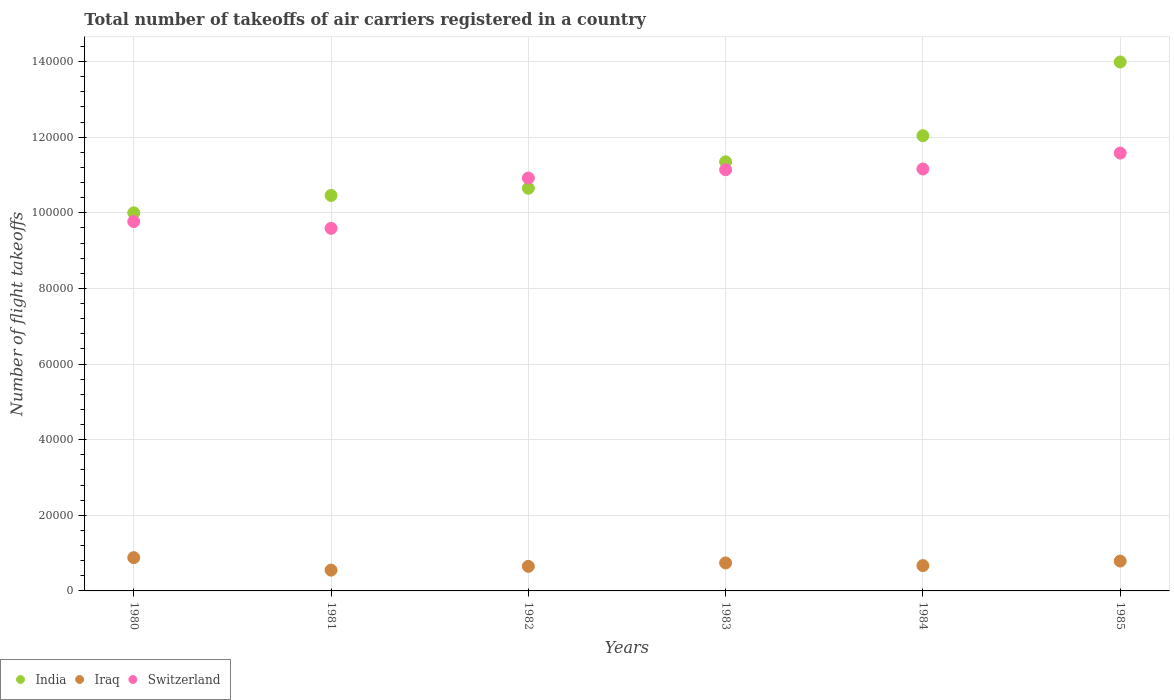How many different coloured dotlines are there?
Make the answer very short. 3. Is the number of dotlines equal to the number of legend labels?
Provide a short and direct response. Yes. What is the total number of flight takeoffs in India in 1981?
Ensure brevity in your answer.  1.05e+05. Across all years, what is the maximum total number of flight takeoffs in Iraq?
Offer a very short reply. 8800. Across all years, what is the minimum total number of flight takeoffs in Switzerland?
Keep it short and to the point. 9.59e+04. What is the total total number of flight takeoffs in India in the graph?
Your answer should be compact. 6.85e+05. What is the difference between the total number of flight takeoffs in India in 1980 and that in 1981?
Your answer should be compact. -4600. What is the difference between the total number of flight takeoffs in Iraq in 1984 and the total number of flight takeoffs in India in 1983?
Offer a very short reply. -1.07e+05. What is the average total number of flight takeoffs in Iraq per year?
Give a very brief answer. 7133.33. In the year 1984, what is the difference between the total number of flight takeoffs in Iraq and total number of flight takeoffs in Switzerland?
Make the answer very short. -1.05e+05. What is the ratio of the total number of flight takeoffs in Switzerland in 1981 to that in 1982?
Make the answer very short. 0.88. What is the difference between the highest and the second highest total number of flight takeoffs in India?
Offer a terse response. 1.95e+04. What is the difference between the highest and the lowest total number of flight takeoffs in Iraq?
Keep it short and to the point. 3300. Is the sum of the total number of flight takeoffs in Iraq in 1980 and 1985 greater than the maximum total number of flight takeoffs in Switzerland across all years?
Keep it short and to the point. No. Is the total number of flight takeoffs in India strictly greater than the total number of flight takeoffs in Switzerland over the years?
Provide a short and direct response. No. How many years are there in the graph?
Ensure brevity in your answer.  6. Are the values on the major ticks of Y-axis written in scientific E-notation?
Provide a succinct answer. No. How are the legend labels stacked?
Your answer should be very brief. Horizontal. What is the title of the graph?
Give a very brief answer. Total number of takeoffs of air carriers registered in a country. Does "Iraq" appear as one of the legend labels in the graph?
Make the answer very short. Yes. What is the label or title of the Y-axis?
Your answer should be compact. Number of flight takeoffs. What is the Number of flight takeoffs in Iraq in 1980?
Ensure brevity in your answer.  8800. What is the Number of flight takeoffs in Switzerland in 1980?
Offer a terse response. 9.77e+04. What is the Number of flight takeoffs of India in 1981?
Ensure brevity in your answer.  1.05e+05. What is the Number of flight takeoffs of Iraq in 1981?
Offer a terse response. 5500. What is the Number of flight takeoffs of Switzerland in 1981?
Make the answer very short. 9.59e+04. What is the Number of flight takeoffs of India in 1982?
Ensure brevity in your answer.  1.06e+05. What is the Number of flight takeoffs in Iraq in 1982?
Offer a terse response. 6500. What is the Number of flight takeoffs in Switzerland in 1982?
Give a very brief answer. 1.09e+05. What is the Number of flight takeoffs in India in 1983?
Provide a short and direct response. 1.14e+05. What is the Number of flight takeoffs in Iraq in 1983?
Ensure brevity in your answer.  7400. What is the Number of flight takeoffs in Switzerland in 1983?
Provide a short and direct response. 1.11e+05. What is the Number of flight takeoffs of India in 1984?
Give a very brief answer. 1.20e+05. What is the Number of flight takeoffs in Iraq in 1984?
Make the answer very short. 6700. What is the Number of flight takeoffs of Switzerland in 1984?
Make the answer very short. 1.12e+05. What is the Number of flight takeoffs in India in 1985?
Your answer should be compact. 1.40e+05. What is the Number of flight takeoffs of Iraq in 1985?
Offer a very short reply. 7900. What is the Number of flight takeoffs in Switzerland in 1985?
Your answer should be compact. 1.16e+05. Across all years, what is the maximum Number of flight takeoffs in India?
Offer a very short reply. 1.40e+05. Across all years, what is the maximum Number of flight takeoffs in Iraq?
Offer a very short reply. 8800. Across all years, what is the maximum Number of flight takeoffs of Switzerland?
Provide a succinct answer. 1.16e+05. Across all years, what is the minimum Number of flight takeoffs of Iraq?
Offer a terse response. 5500. Across all years, what is the minimum Number of flight takeoffs of Switzerland?
Your answer should be very brief. 9.59e+04. What is the total Number of flight takeoffs in India in the graph?
Offer a very short reply. 6.85e+05. What is the total Number of flight takeoffs of Iraq in the graph?
Your answer should be compact. 4.28e+04. What is the total Number of flight takeoffs in Switzerland in the graph?
Offer a very short reply. 6.42e+05. What is the difference between the Number of flight takeoffs of India in 1980 and that in 1981?
Your response must be concise. -4600. What is the difference between the Number of flight takeoffs in Iraq in 1980 and that in 1981?
Provide a short and direct response. 3300. What is the difference between the Number of flight takeoffs in Switzerland in 1980 and that in 1981?
Provide a succinct answer. 1800. What is the difference between the Number of flight takeoffs in India in 1980 and that in 1982?
Keep it short and to the point. -6500. What is the difference between the Number of flight takeoffs in Iraq in 1980 and that in 1982?
Provide a succinct answer. 2300. What is the difference between the Number of flight takeoffs in Switzerland in 1980 and that in 1982?
Offer a very short reply. -1.15e+04. What is the difference between the Number of flight takeoffs in India in 1980 and that in 1983?
Provide a short and direct response. -1.35e+04. What is the difference between the Number of flight takeoffs of Iraq in 1980 and that in 1983?
Provide a succinct answer. 1400. What is the difference between the Number of flight takeoffs in Switzerland in 1980 and that in 1983?
Provide a succinct answer. -1.37e+04. What is the difference between the Number of flight takeoffs in India in 1980 and that in 1984?
Your response must be concise. -2.04e+04. What is the difference between the Number of flight takeoffs in Iraq in 1980 and that in 1984?
Your response must be concise. 2100. What is the difference between the Number of flight takeoffs in Switzerland in 1980 and that in 1984?
Your response must be concise. -1.39e+04. What is the difference between the Number of flight takeoffs in India in 1980 and that in 1985?
Provide a succinct answer. -3.99e+04. What is the difference between the Number of flight takeoffs of Iraq in 1980 and that in 1985?
Provide a succinct answer. 900. What is the difference between the Number of flight takeoffs of Switzerland in 1980 and that in 1985?
Ensure brevity in your answer.  -1.81e+04. What is the difference between the Number of flight takeoffs in India in 1981 and that in 1982?
Keep it short and to the point. -1900. What is the difference between the Number of flight takeoffs of Iraq in 1981 and that in 1982?
Give a very brief answer. -1000. What is the difference between the Number of flight takeoffs of Switzerland in 1981 and that in 1982?
Ensure brevity in your answer.  -1.33e+04. What is the difference between the Number of flight takeoffs of India in 1981 and that in 1983?
Keep it short and to the point. -8900. What is the difference between the Number of flight takeoffs of Iraq in 1981 and that in 1983?
Make the answer very short. -1900. What is the difference between the Number of flight takeoffs in Switzerland in 1981 and that in 1983?
Keep it short and to the point. -1.55e+04. What is the difference between the Number of flight takeoffs in India in 1981 and that in 1984?
Your answer should be very brief. -1.58e+04. What is the difference between the Number of flight takeoffs in Iraq in 1981 and that in 1984?
Offer a terse response. -1200. What is the difference between the Number of flight takeoffs in Switzerland in 1981 and that in 1984?
Provide a succinct answer. -1.57e+04. What is the difference between the Number of flight takeoffs of India in 1981 and that in 1985?
Offer a very short reply. -3.53e+04. What is the difference between the Number of flight takeoffs of Iraq in 1981 and that in 1985?
Give a very brief answer. -2400. What is the difference between the Number of flight takeoffs of Switzerland in 1981 and that in 1985?
Make the answer very short. -1.99e+04. What is the difference between the Number of flight takeoffs of India in 1982 and that in 1983?
Provide a short and direct response. -7000. What is the difference between the Number of flight takeoffs in Iraq in 1982 and that in 1983?
Offer a terse response. -900. What is the difference between the Number of flight takeoffs of Switzerland in 1982 and that in 1983?
Make the answer very short. -2200. What is the difference between the Number of flight takeoffs in India in 1982 and that in 1984?
Give a very brief answer. -1.39e+04. What is the difference between the Number of flight takeoffs of Iraq in 1982 and that in 1984?
Provide a short and direct response. -200. What is the difference between the Number of flight takeoffs of Switzerland in 1982 and that in 1984?
Keep it short and to the point. -2400. What is the difference between the Number of flight takeoffs in India in 1982 and that in 1985?
Your answer should be very brief. -3.34e+04. What is the difference between the Number of flight takeoffs in Iraq in 1982 and that in 1985?
Keep it short and to the point. -1400. What is the difference between the Number of flight takeoffs in Switzerland in 1982 and that in 1985?
Give a very brief answer. -6600. What is the difference between the Number of flight takeoffs in India in 1983 and that in 1984?
Your answer should be very brief. -6900. What is the difference between the Number of flight takeoffs in Iraq in 1983 and that in 1984?
Offer a very short reply. 700. What is the difference between the Number of flight takeoffs in Switzerland in 1983 and that in 1984?
Make the answer very short. -200. What is the difference between the Number of flight takeoffs in India in 1983 and that in 1985?
Offer a very short reply. -2.64e+04. What is the difference between the Number of flight takeoffs in Iraq in 1983 and that in 1985?
Ensure brevity in your answer.  -500. What is the difference between the Number of flight takeoffs in Switzerland in 1983 and that in 1985?
Your response must be concise. -4400. What is the difference between the Number of flight takeoffs in India in 1984 and that in 1985?
Your answer should be very brief. -1.95e+04. What is the difference between the Number of flight takeoffs in Iraq in 1984 and that in 1985?
Your answer should be very brief. -1200. What is the difference between the Number of flight takeoffs of Switzerland in 1984 and that in 1985?
Provide a succinct answer. -4200. What is the difference between the Number of flight takeoffs of India in 1980 and the Number of flight takeoffs of Iraq in 1981?
Your answer should be very brief. 9.45e+04. What is the difference between the Number of flight takeoffs of India in 1980 and the Number of flight takeoffs of Switzerland in 1981?
Give a very brief answer. 4100. What is the difference between the Number of flight takeoffs of Iraq in 1980 and the Number of flight takeoffs of Switzerland in 1981?
Offer a terse response. -8.71e+04. What is the difference between the Number of flight takeoffs of India in 1980 and the Number of flight takeoffs of Iraq in 1982?
Offer a very short reply. 9.35e+04. What is the difference between the Number of flight takeoffs of India in 1980 and the Number of flight takeoffs of Switzerland in 1982?
Provide a short and direct response. -9200. What is the difference between the Number of flight takeoffs of Iraq in 1980 and the Number of flight takeoffs of Switzerland in 1982?
Offer a terse response. -1.00e+05. What is the difference between the Number of flight takeoffs in India in 1980 and the Number of flight takeoffs in Iraq in 1983?
Make the answer very short. 9.26e+04. What is the difference between the Number of flight takeoffs of India in 1980 and the Number of flight takeoffs of Switzerland in 1983?
Give a very brief answer. -1.14e+04. What is the difference between the Number of flight takeoffs in Iraq in 1980 and the Number of flight takeoffs in Switzerland in 1983?
Provide a short and direct response. -1.03e+05. What is the difference between the Number of flight takeoffs of India in 1980 and the Number of flight takeoffs of Iraq in 1984?
Your answer should be very brief. 9.33e+04. What is the difference between the Number of flight takeoffs in India in 1980 and the Number of flight takeoffs in Switzerland in 1984?
Your answer should be compact. -1.16e+04. What is the difference between the Number of flight takeoffs in Iraq in 1980 and the Number of flight takeoffs in Switzerland in 1984?
Provide a short and direct response. -1.03e+05. What is the difference between the Number of flight takeoffs of India in 1980 and the Number of flight takeoffs of Iraq in 1985?
Give a very brief answer. 9.21e+04. What is the difference between the Number of flight takeoffs in India in 1980 and the Number of flight takeoffs in Switzerland in 1985?
Provide a short and direct response. -1.58e+04. What is the difference between the Number of flight takeoffs in Iraq in 1980 and the Number of flight takeoffs in Switzerland in 1985?
Give a very brief answer. -1.07e+05. What is the difference between the Number of flight takeoffs of India in 1981 and the Number of flight takeoffs of Iraq in 1982?
Your answer should be very brief. 9.81e+04. What is the difference between the Number of flight takeoffs of India in 1981 and the Number of flight takeoffs of Switzerland in 1982?
Your response must be concise. -4600. What is the difference between the Number of flight takeoffs in Iraq in 1981 and the Number of flight takeoffs in Switzerland in 1982?
Your answer should be compact. -1.04e+05. What is the difference between the Number of flight takeoffs in India in 1981 and the Number of flight takeoffs in Iraq in 1983?
Your answer should be compact. 9.72e+04. What is the difference between the Number of flight takeoffs of India in 1981 and the Number of flight takeoffs of Switzerland in 1983?
Ensure brevity in your answer.  -6800. What is the difference between the Number of flight takeoffs in Iraq in 1981 and the Number of flight takeoffs in Switzerland in 1983?
Offer a terse response. -1.06e+05. What is the difference between the Number of flight takeoffs of India in 1981 and the Number of flight takeoffs of Iraq in 1984?
Your response must be concise. 9.79e+04. What is the difference between the Number of flight takeoffs in India in 1981 and the Number of flight takeoffs in Switzerland in 1984?
Make the answer very short. -7000. What is the difference between the Number of flight takeoffs in Iraq in 1981 and the Number of flight takeoffs in Switzerland in 1984?
Your response must be concise. -1.06e+05. What is the difference between the Number of flight takeoffs in India in 1981 and the Number of flight takeoffs in Iraq in 1985?
Provide a succinct answer. 9.67e+04. What is the difference between the Number of flight takeoffs of India in 1981 and the Number of flight takeoffs of Switzerland in 1985?
Give a very brief answer. -1.12e+04. What is the difference between the Number of flight takeoffs in Iraq in 1981 and the Number of flight takeoffs in Switzerland in 1985?
Your answer should be compact. -1.10e+05. What is the difference between the Number of flight takeoffs of India in 1982 and the Number of flight takeoffs of Iraq in 1983?
Your answer should be compact. 9.91e+04. What is the difference between the Number of flight takeoffs of India in 1982 and the Number of flight takeoffs of Switzerland in 1983?
Provide a short and direct response. -4900. What is the difference between the Number of flight takeoffs in Iraq in 1982 and the Number of flight takeoffs in Switzerland in 1983?
Give a very brief answer. -1.05e+05. What is the difference between the Number of flight takeoffs in India in 1982 and the Number of flight takeoffs in Iraq in 1984?
Make the answer very short. 9.98e+04. What is the difference between the Number of flight takeoffs of India in 1982 and the Number of flight takeoffs of Switzerland in 1984?
Give a very brief answer. -5100. What is the difference between the Number of flight takeoffs of Iraq in 1982 and the Number of flight takeoffs of Switzerland in 1984?
Your answer should be compact. -1.05e+05. What is the difference between the Number of flight takeoffs in India in 1982 and the Number of flight takeoffs in Iraq in 1985?
Your response must be concise. 9.86e+04. What is the difference between the Number of flight takeoffs in India in 1982 and the Number of flight takeoffs in Switzerland in 1985?
Provide a short and direct response. -9300. What is the difference between the Number of flight takeoffs of Iraq in 1982 and the Number of flight takeoffs of Switzerland in 1985?
Make the answer very short. -1.09e+05. What is the difference between the Number of flight takeoffs of India in 1983 and the Number of flight takeoffs of Iraq in 1984?
Provide a succinct answer. 1.07e+05. What is the difference between the Number of flight takeoffs of India in 1983 and the Number of flight takeoffs of Switzerland in 1984?
Offer a terse response. 1900. What is the difference between the Number of flight takeoffs of Iraq in 1983 and the Number of flight takeoffs of Switzerland in 1984?
Offer a terse response. -1.04e+05. What is the difference between the Number of flight takeoffs of India in 1983 and the Number of flight takeoffs of Iraq in 1985?
Give a very brief answer. 1.06e+05. What is the difference between the Number of flight takeoffs of India in 1983 and the Number of flight takeoffs of Switzerland in 1985?
Provide a succinct answer. -2300. What is the difference between the Number of flight takeoffs in Iraq in 1983 and the Number of flight takeoffs in Switzerland in 1985?
Give a very brief answer. -1.08e+05. What is the difference between the Number of flight takeoffs in India in 1984 and the Number of flight takeoffs in Iraq in 1985?
Your response must be concise. 1.12e+05. What is the difference between the Number of flight takeoffs in India in 1984 and the Number of flight takeoffs in Switzerland in 1985?
Ensure brevity in your answer.  4600. What is the difference between the Number of flight takeoffs of Iraq in 1984 and the Number of flight takeoffs of Switzerland in 1985?
Make the answer very short. -1.09e+05. What is the average Number of flight takeoffs in India per year?
Provide a short and direct response. 1.14e+05. What is the average Number of flight takeoffs of Iraq per year?
Your answer should be very brief. 7133.33. What is the average Number of flight takeoffs of Switzerland per year?
Give a very brief answer. 1.07e+05. In the year 1980, what is the difference between the Number of flight takeoffs of India and Number of flight takeoffs of Iraq?
Provide a succinct answer. 9.12e+04. In the year 1980, what is the difference between the Number of flight takeoffs of India and Number of flight takeoffs of Switzerland?
Offer a terse response. 2300. In the year 1980, what is the difference between the Number of flight takeoffs in Iraq and Number of flight takeoffs in Switzerland?
Give a very brief answer. -8.89e+04. In the year 1981, what is the difference between the Number of flight takeoffs of India and Number of flight takeoffs of Iraq?
Your answer should be very brief. 9.91e+04. In the year 1981, what is the difference between the Number of flight takeoffs in India and Number of flight takeoffs in Switzerland?
Give a very brief answer. 8700. In the year 1981, what is the difference between the Number of flight takeoffs of Iraq and Number of flight takeoffs of Switzerland?
Provide a short and direct response. -9.04e+04. In the year 1982, what is the difference between the Number of flight takeoffs of India and Number of flight takeoffs of Switzerland?
Keep it short and to the point. -2700. In the year 1982, what is the difference between the Number of flight takeoffs in Iraq and Number of flight takeoffs in Switzerland?
Your answer should be compact. -1.03e+05. In the year 1983, what is the difference between the Number of flight takeoffs in India and Number of flight takeoffs in Iraq?
Provide a succinct answer. 1.06e+05. In the year 1983, what is the difference between the Number of flight takeoffs of India and Number of flight takeoffs of Switzerland?
Give a very brief answer. 2100. In the year 1983, what is the difference between the Number of flight takeoffs in Iraq and Number of flight takeoffs in Switzerland?
Your answer should be very brief. -1.04e+05. In the year 1984, what is the difference between the Number of flight takeoffs of India and Number of flight takeoffs of Iraq?
Offer a terse response. 1.14e+05. In the year 1984, what is the difference between the Number of flight takeoffs of India and Number of flight takeoffs of Switzerland?
Ensure brevity in your answer.  8800. In the year 1984, what is the difference between the Number of flight takeoffs in Iraq and Number of flight takeoffs in Switzerland?
Provide a short and direct response. -1.05e+05. In the year 1985, what is the difference between the Number of flight takeoffs in India and Number of flight takeoffs in Iraq?
Your answer should be very brief. 1.32e+05. In the year 1985, what is the difference between the Number of flight takeoffs of India and Number of flight takeoffs of Switzerland?
Your answer should be very brief. 2.41e+04. In the year 1985, what is the difference between the Number of flight takeoffs of Iraq and Number of flight takeoffs of Switzerland?
Ensure brevity in your answer.  -1.08e+05. What is the ratio of the Number of flight takeoffs of India in 1980 to that in 1981?
Your answer should be compact. 0.96. What is the ratio of the Number of flight takeoffs in Iraq in 1980 to that in 1981?
Ensure brevity in your answer.  1.6. What is the ratio of the Number of flight takeoffs of Switzerland in 1980 to that in 1981?
Offer a very short reply. 1.02. What is the ratio of the Number of flight takeoffs of India in 1980 to that in 1982?
Provide a short and direct response. 0.94. What is the ratio of the Number of flight takeoffs in Iraq in 1980 to that in 1982?
Give a very brief answer. 1.35. What is the ratio of the Number of flight takeoffs in Switzerland in 1980 to that in 1982?
Give a very brief answer. 0.89. What is the ratio of the Number of flight takeoffs of India in 1980 to that in 1983?
Keep it short and to the point. 0.88. What is the ratio of the Number of flight takeoffs of Iraq in 1980 to that in 1983?
Ensure brevity in your answer.  1.19. What is the ratio of the Number of flight takeoffs in Switzerland in 1980 to that in 1983?
Offer a terse response. 0.88. What is the ratio of the Number of flight takeoffs in India in 1980 to that in 1984?
Ensure brevity in your answer.  0.83. What is the ratio of the Number of flight takeoffs in Iraq in 1980 to that in 1984?
Ensure brevity in your answer.  1.31. What is the ratio of the Number of flight takeoffs of Switzerland in 1980 to that in 1984?
Your response must be concise. 0.88. What is the ratio of the Number of flight takeoffs of India in 1980 to that in 1985?
Make the answer very short. 0.71. What is the ratio of the Number of flight takeoffs in Iraq in 1980 to that in 1985?
Offer a very short reply. 1.11. What is the ratio of the Number of flight takeoffs in Switzerland in 1980 to that in 1985?
Ensure brevity in your answer.  0.84. What is the ratio of the Number of flight takeoffs of India in 1981 to that in 1982?
Make the answer very short. 0.98. What is the ratio of the Number of flight takeoffs of Iraq in 1981 to that in 1982?
Offer a terse response. 0.85. What is the ratio of the Number of flight takeoffs in Switzerland in 1981 to that in 1982?
Offer a terse response. 0.88. What is the ratio of the Number of flight takeoffs of India in 1981 to that in 1983?
Your response must be concise. 0.92. What is the ratio of the Number of flight takeoffs in Iraq in 1981 to that in 1983?
Keep it short and to the point. 0.74. What is the ratio of the Number of flight takeoffs in Switzerland in 1981 to that in 1983?
Your answer should be very brief. 0.86. What is the ratio of the Number of flight takeoffs in India in 1981 to that in 1984?
Provide a short and direct response. 0.87. What is the ratio of the Number of flight takeoffs in Iraq in 1981 to that in 1984?
Make the answer very short. 0.82. What is the ratio of the Number of flight takeoffs of Switzerland in 1981 to that in 1984?
Provide a succinct answer. 0.86. What is the ratio of the Number of flight takeoffs of India in 1981 to that in 1985?
Give a very brief answer. 0.75. What is the ratio of the Number of flight takeoffs of Iraq in 1981 to that in 1985?
Make the answer very short. 0.7. What is the ratio of the Number of flight takeoffs of Switzerland in 1981 to that in 1985?
Your response must be concise. 0.83. What is the ratio of the Number of flight takeoffs in India in 1982 to that in 1983?
Ensure brevity in your answer.  0.94. What is the ratio of the Number of flight takeoffs in Iraq in 1982 to that in 1983?
Offer a very short reply. 0.88. What is the ratio of the Number of flight takeoffs of Switzerland in 1982 to that in 1983?
Your answer should be very brief. 0.98. What is the ratio of the Number of flight takeoffs of India in 1982 to that in 1984?
Offer a terse response. 0.88. What is the ratio of the Number of flight takeoffs of Iraq in 1982 to that in 1984?
Make the answer very short. 0.97. What is the ratio of the Number of flight takeoffs of Switzerland in 1982 to that in 1984?
Keep it short and to the point. 0.98. What is the ratio of the Number of flight takeoffs in India in 1982 to that in 1985?
Your answer should be compact. 0.76. What is the ratio of the Number of flight takeoffs in Iraq in 1982 to that in 1985?
Keep it short and to the point. 0.82. What is the ratio of the Number of flight takeoffs in Switzerland in 1982 to that in 1985?
Provide a succinct answer. 0.94. What is the ratio of the Number of flight takeoffs of India in 1983 to that in 1984?
Keep it short and to the point. 0.94. What is the ratio of the Number of flight takeoffs of Iraq in 1983 to that in 1984?
Provide a succinct answer. 1.1. What is the ratio of the Number of flight takeoffs of Switzerland in 1983 to that in 1984?
Your answer should be very brief. 1. What is the ratio of the Number of flight takeoffs of India in 1983 to that in 1985?
Offer a very short reply. 0.81. What is the ratio of the Number of flight takeoffs of Iraq in 1983 to that in 1985?
Your answer should be compact. 0.94. What is the ratio of the Number of flight takeoffs in Switzerland in 1983 to that in 1985?
Provide a succinct answer. 0.96. What is the ratio of the Number of flight takeoffs of India in 1984 to that in 1985?
Keep it short and to the point. 0.86. What is the ratio of the Number of flight takeoffs of Iraq in 1984 to that in 1985?
Give a very brief answer. 0.85. What is the ratio of the Number of flight takeoffs of Switzerland in 1984 to that in 1985?
Give a very brief answer. 0.96. What is the difference between the highest and the second highest Number of flight takeoffs of India?
Give a very brief answer. 1.95e+04. What is the difference between the highest and the second highest Number of flight takeoffs of Iraq?
Keep it short and to the point. 900. What is the difference between the highest and the second highest Number of flight takeoffs of Switzerland?
Provide a short and direct response. 4200. What is the difference between the highest and the lowest Number of flight takeoffs in India?
Provide a short and direct response. 3.99e+04. What is the difference between the highest and the lowest Number of flight takeoffs in Iraq?
Give a very brief answer. 3300. What is the difference between the highest and the lowest Number of flight takeoffs of Switzerland?
Ensure brevity in your answer.  1.99e+04. 